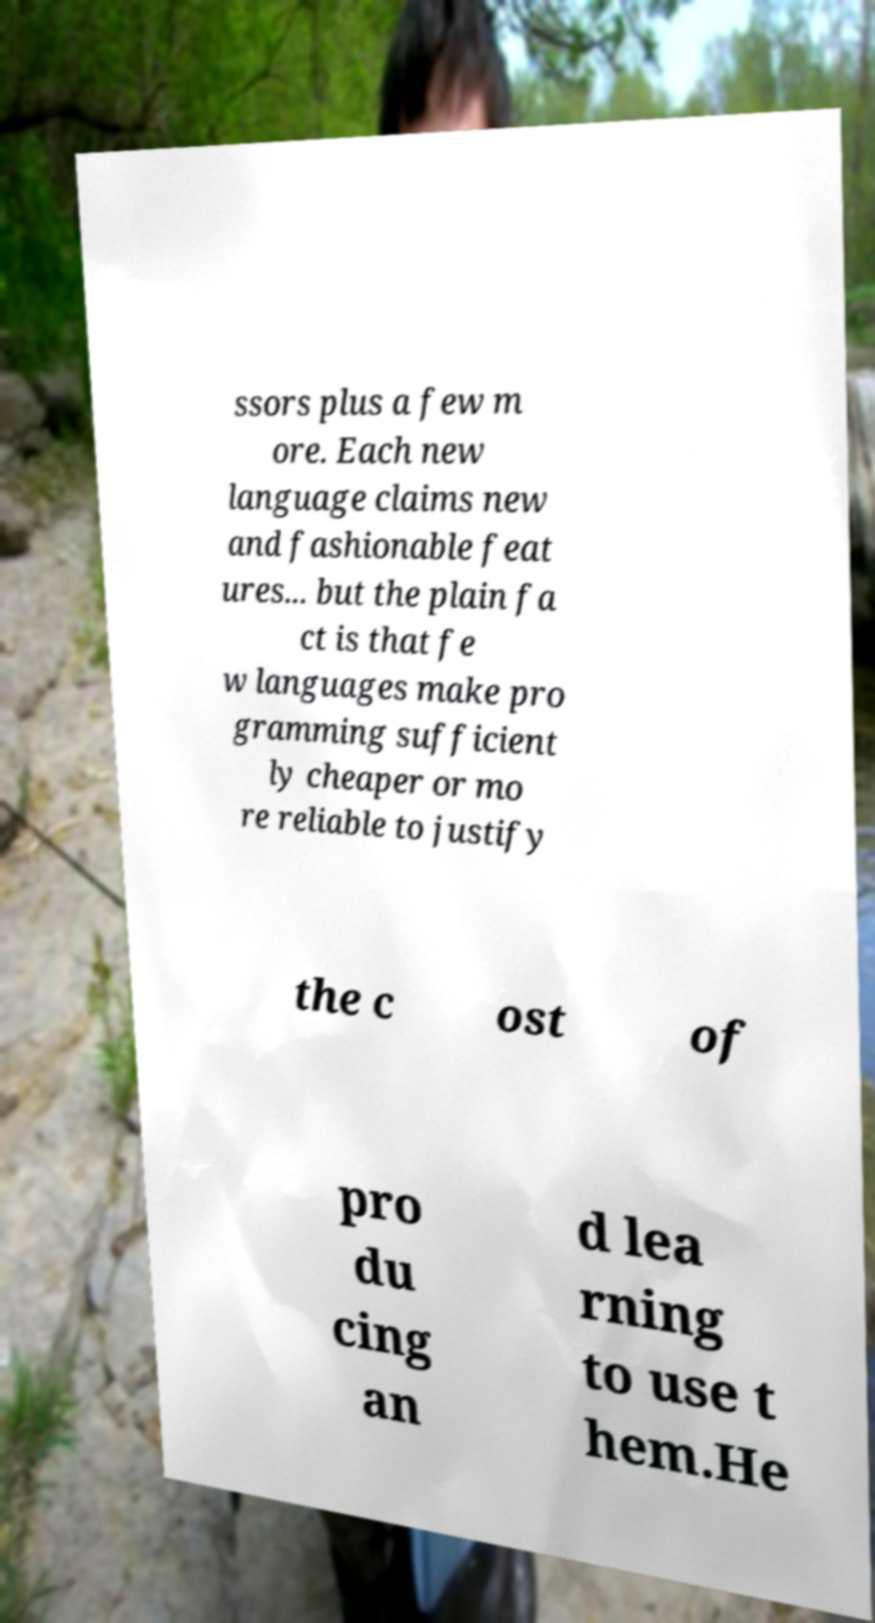What messages or text are displayed in this image? I need them in a readable, typed format. ssors plus a few m ore. Each new language claims new and fashionable feat ures... but the plain fa ct is that fe w languages make pro gramming sufficient ly cheaper or mo re reliable to justify the c ost of pro du cing an d lea rning to use t hem.He 